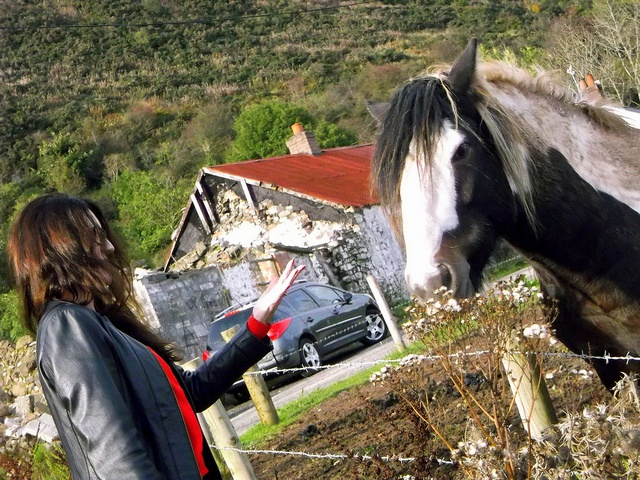Describe the objects in this image and their specific colors. I can see horse in gray, black, white, and darkgray tones, people in gray, black, and darkgray tones, and car in gray, black, and darkgray tones in this image. 